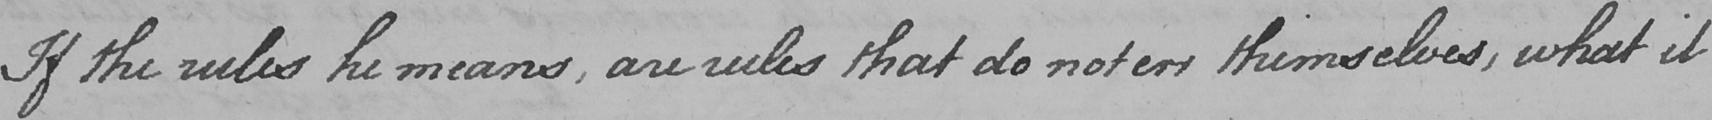Please transcribe the handwritten text in this image. If the rules he means , are rules that do not err themselves , what it 